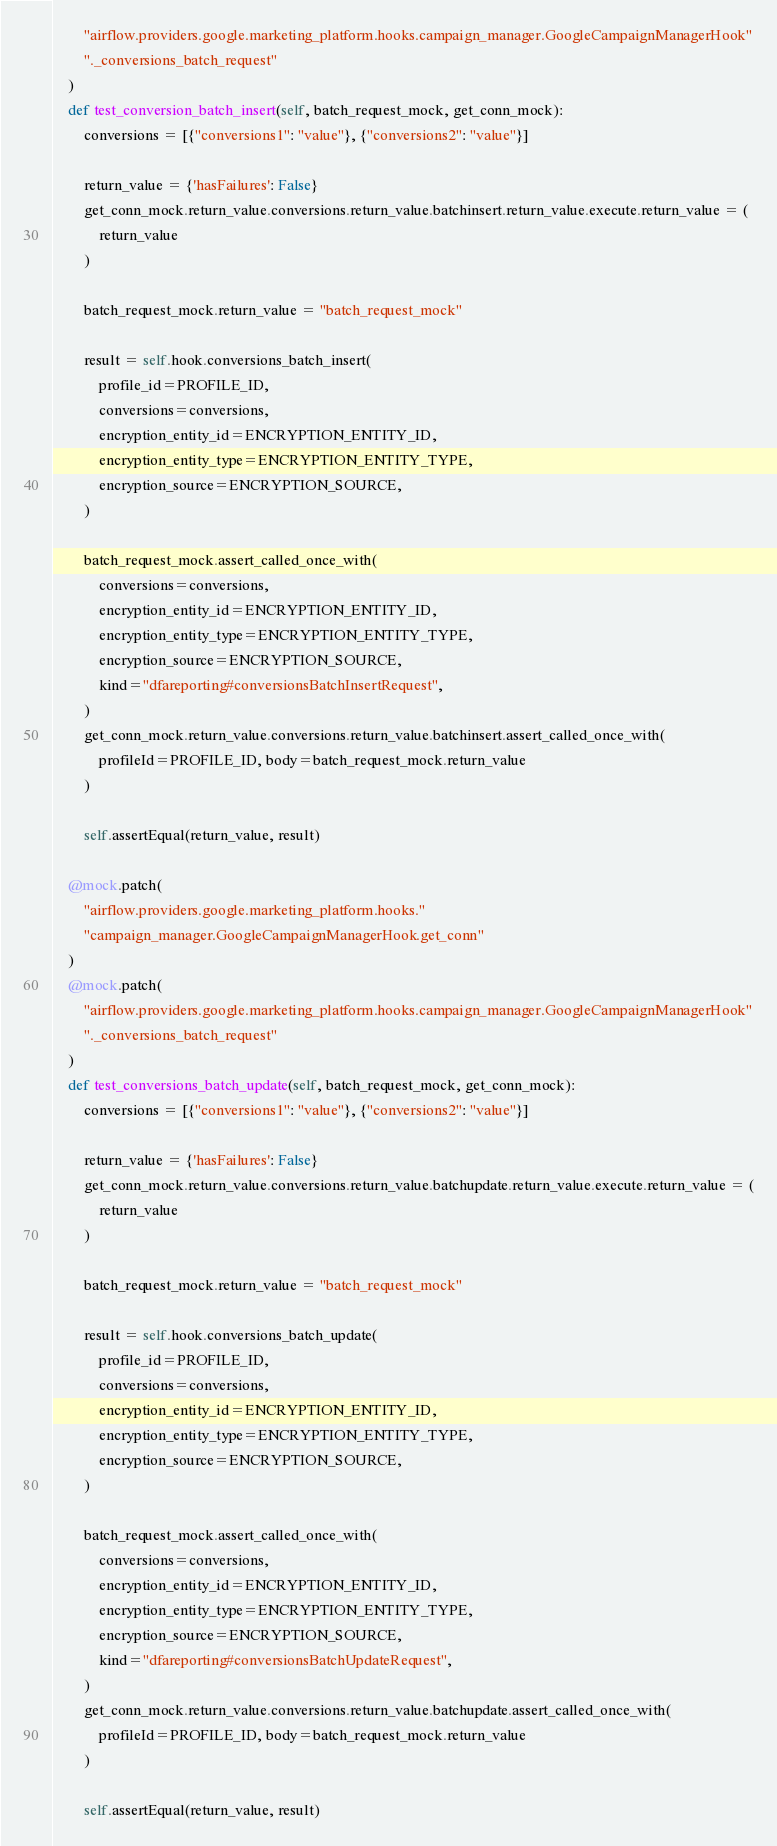<code> <loc_0><loc_0><loc_500><loc_500><_Python_>        "airflow.providers.google.marketing_platform.hooks.campaign_manager.GoogleCampaignManagerHook"
        "._conversions_batch_request"
    )
    def test_conversion_batch_insert(self, batch_request_mock, get_conn_mock):
        conversions = [{"conversions1": "value"}, {"conversions2": "value"}]

        return_value = {'hasFailures': False}
        get_conn_mock.return_value.conversions.return_value.batchinsert.return_value.execute.return_value = (
            return_value
        )

        batch_request_mock.return_value = "batch_request_mock"

        result = self.hook.conversions_batch_insert(
            profile_id=PROFILE_ID,
            conversions=conversions,
            encryption_entity_id=ENCRYPTION_ENTITY_ID,
            encryption_entity_type=ENCRYPTION_ENTITY_TYPE,
            encryption_source=ENCRYPTION_SOURCE,
        )

        batch_request_mock.assert_called_once_with(
            conversions=conversions,
            encryption_entity_id=ENCRYPTION_ENTITY_ID,
            encryption_entity_type=ENCRYPTION_ENTITY_TYPE,
            encryption_source=ENCRYPTION_SOURCE,
            kind="dfareporting#conversionsBatchInsertRequest",
        )
        get_conn_mock.return_value.conversions.return_value.batchinsert.assert_called_once_with(
            profileId=PROFILE_ID, body=batch_request_mock.return_value
        )

        self.assertEqual(return_value, result)

    @mock.patch(
        "airflow.providers.google.marketing_platform.hooks."
        "campaign_manager.GoogleCampaignManagerHook.get_conn"
    )
    @mock.patch(
        "airflow.providers.google.marketing_platform.hooks.campaign_manager.GoogleCampaignManagerHook"
        "._conversions_batch_request"
    )
    def test_conversions_batch_update(self, batch_request_mock, get_conn_mock):
        conversions = [{"conversions1": "value"}, {"conversions2": "value"}]

        return_value = {'hasFailures': False}
        get_conn_mock.return_value.conversions.return_value.batchupdate.return_value.execute.return_value = (
            return_value
        )

        batch_request_mock.return_value = "batch_request_mock"

        result = self.hook.conversions_batch_update(
            profile_id=PROFILE_ID,
            conversions=conversions,
            encryption_entity_id=ENCRYPTION_ENTITY_ID,
            encryption_entity_type=ENCRYPTION_ENTITY_TYPE,
            encryption_source=ENCRYPTION_SOURCE,
        )

        batch_request_mock.assert_called_once_with(
            conversions=conversions,
            encryption_entity_id=ENCRYPTION_ENTITY_ID,
            encryption_entity_type=ENCRYPTION_ENTITY_TYPE,
            encryption_source=ENCRYPTION_SOURCE,
            kind="dfareporting#conversionsBatchUpdateRequest",
        )
        get_conn_mock.return_value.conversions.return_value.batchupdate.assert_called_once_with(
            profileId=PROFILE_ID, body=batch_request_mock.return_value
        )

        self.assertEqual(return_value, result)
</code> 